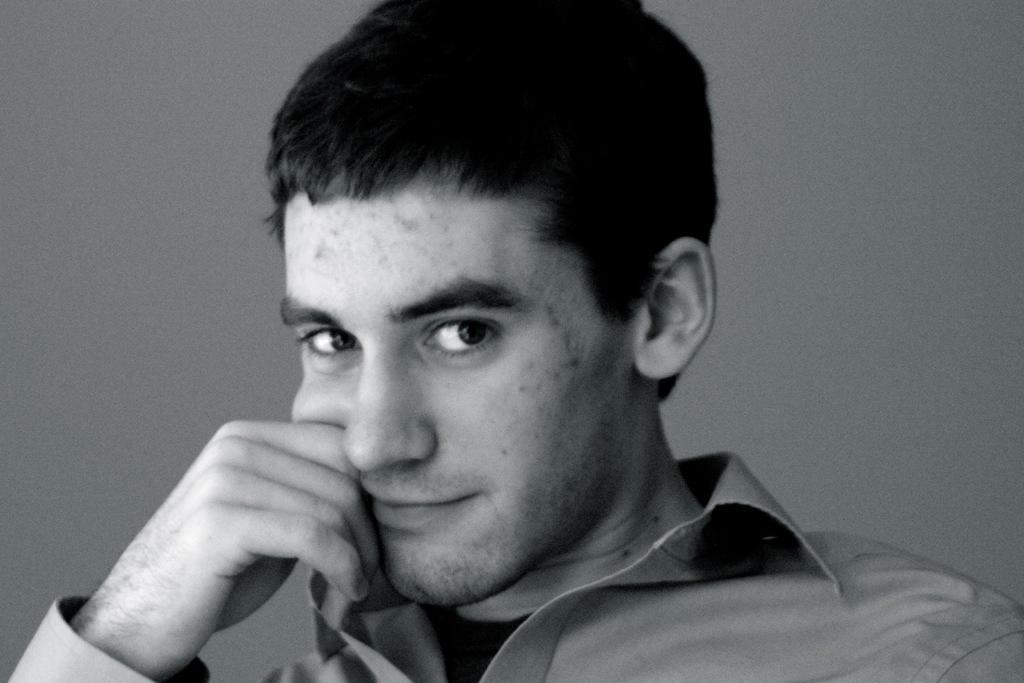Who is present in the image? There is a man in the image. What is the man wearing? The man is wearing a gray shirt. What can be seen in the background of the image? The background of the image is gray in color. What is the spark rate of the patch on the man's shirt in the image? There is no spark or patch present on the man's shirt in the image. 